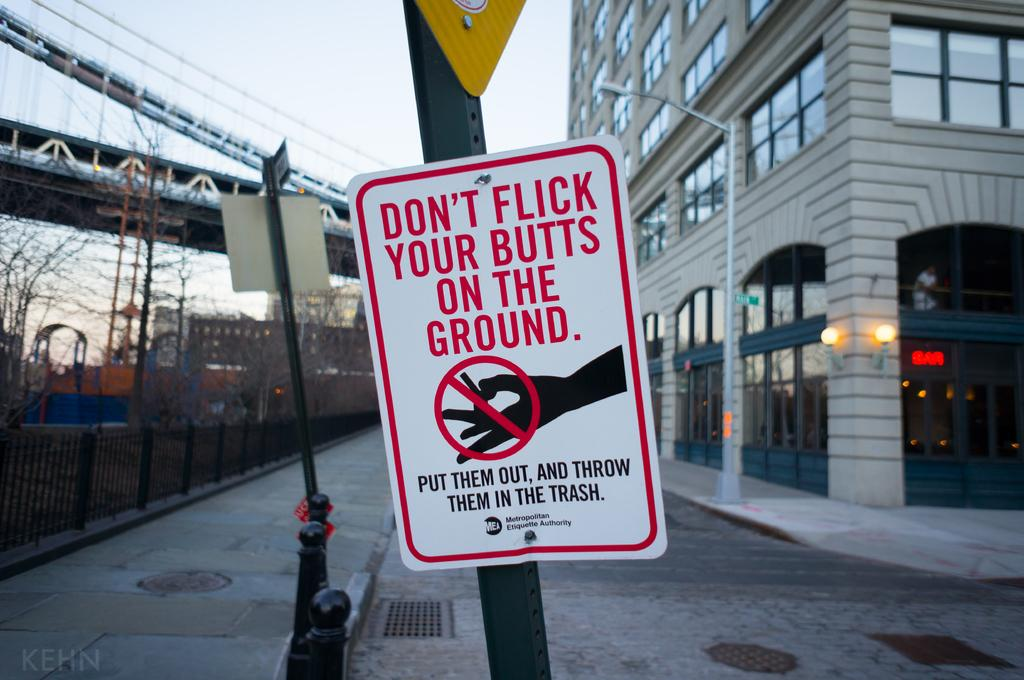<image>
Give a short and clear explanation of the subsequent image. A sick reading 'don't flick your butts on the ground.' 